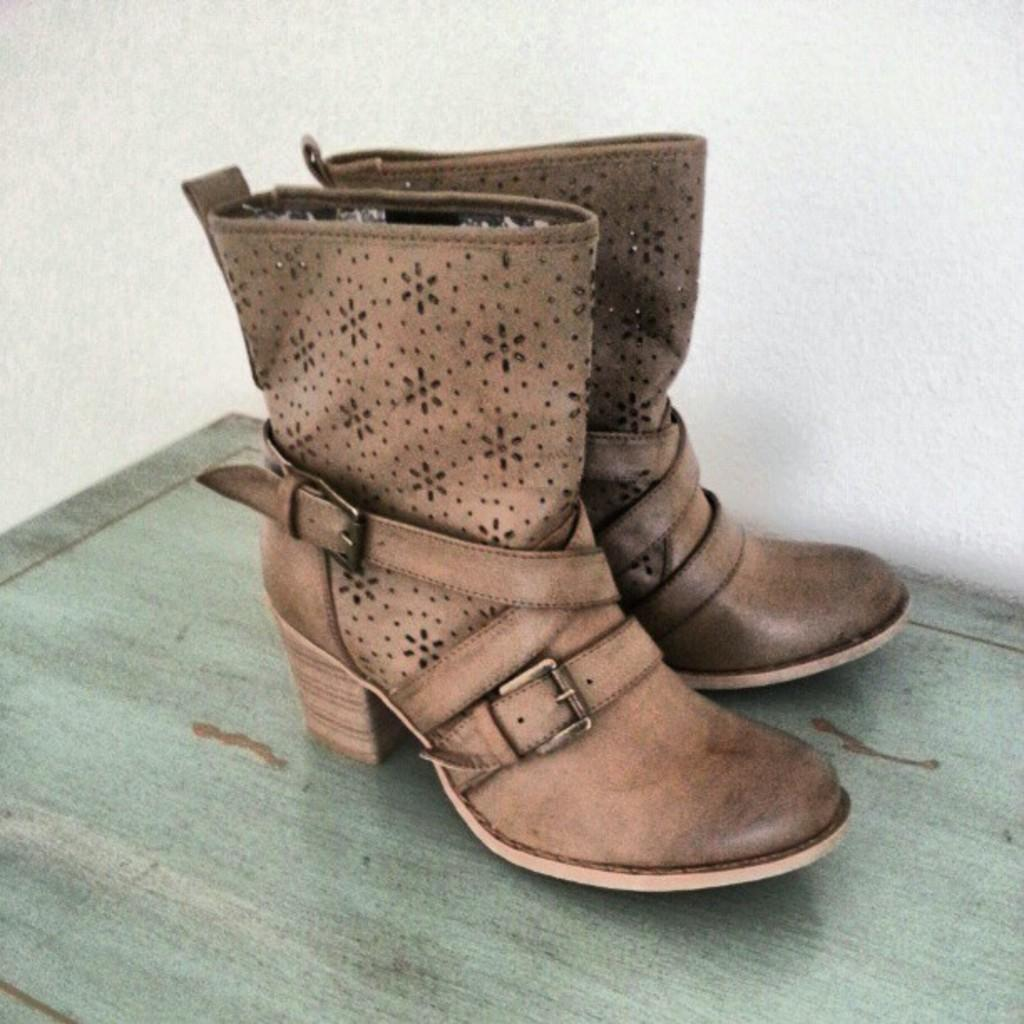What type of objects can be seen in the image? There are shoes in the image. Can you tell me how many potatoes are visible in the image? There are no potatoes present in the image; it only features shoes. What type of yarn is being used to create the shoes in the image? The image does not provide information about the materials used to create the shoes, so it is not possible to determine if yarn is involved. 